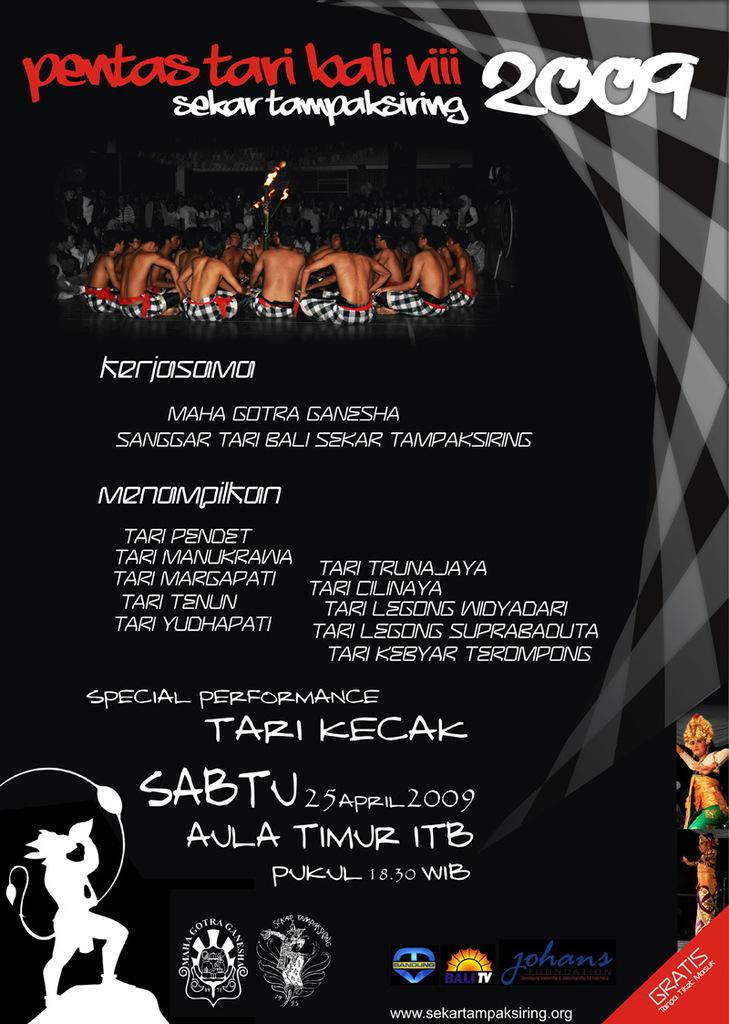What year is on this poster?
Make the answer very short. 2009. What month does this event take place in?
Your answer should be very brief. April. 